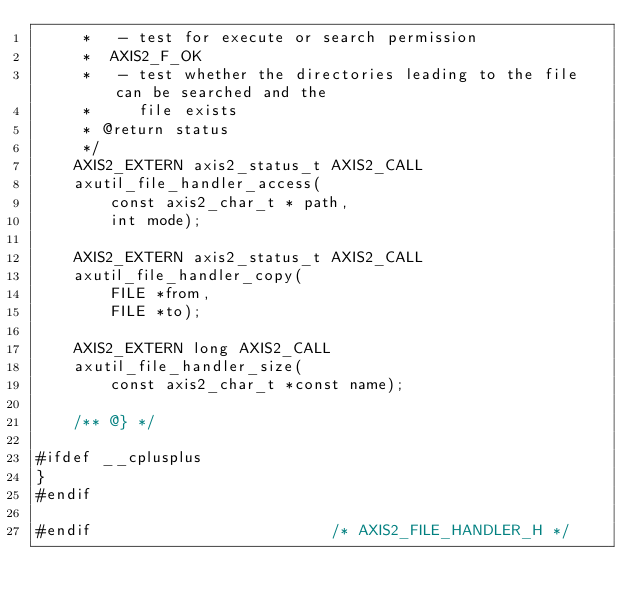<code> <loc_0><loc_0><loc_500><loc_500><_C_>     *   - test for execute or search permission
     *  AXIS2_F_OK
     *   - test whether the directories leading to the file can be searched and the
     *     file exists
     * @return status
     */
    AXIS2_EXTERN axis2_status_t AXIS2_CALL
    axutil_file_handler_access(
        const axis2_char_t * path,
        int mode);

    AXIS2_EXTERN axis2_status_t AXIS2_CALL
    axutil_file_handler_copy(
        FILE *from,
        FILE *to);

    AXIS2_EXTERN long AXIS2_CALL
    axutil_file_handler_size(
        const axis2_char_t *const name);

    /** @} */

#ifdef __cplusplus
}
#endif

#endif                          /* AXIS2_FILE_HANDLER_H */
</code> 